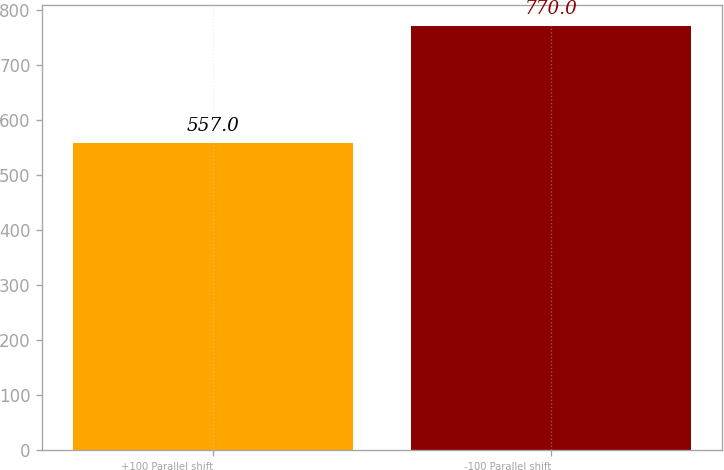Convert chart. <chart><loc_0><loc_0><loc_500><loc_500><bar_chart><fcel>+100 Parallel shift<fcel>-100 Parallel shift<nl><fcel>557<fcel>770<nl></chart> 